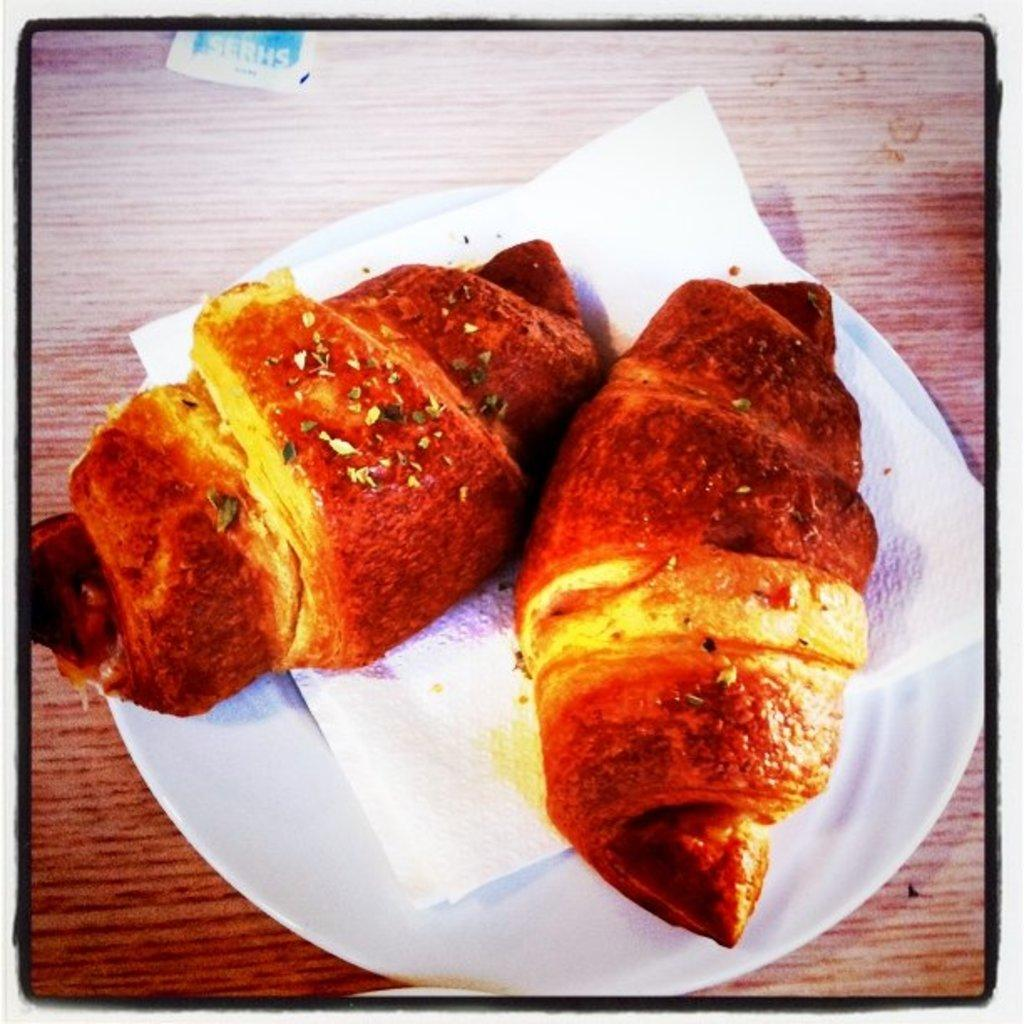What is present on the plate in the image? There is a food item on the plate in the image. How is the food item presented on the plate? The food item is on tissue paper. What type of yak can be seen grazing in the background of the image? There is no yak present in the image; it only features a plate with a food item on tissue paper. 